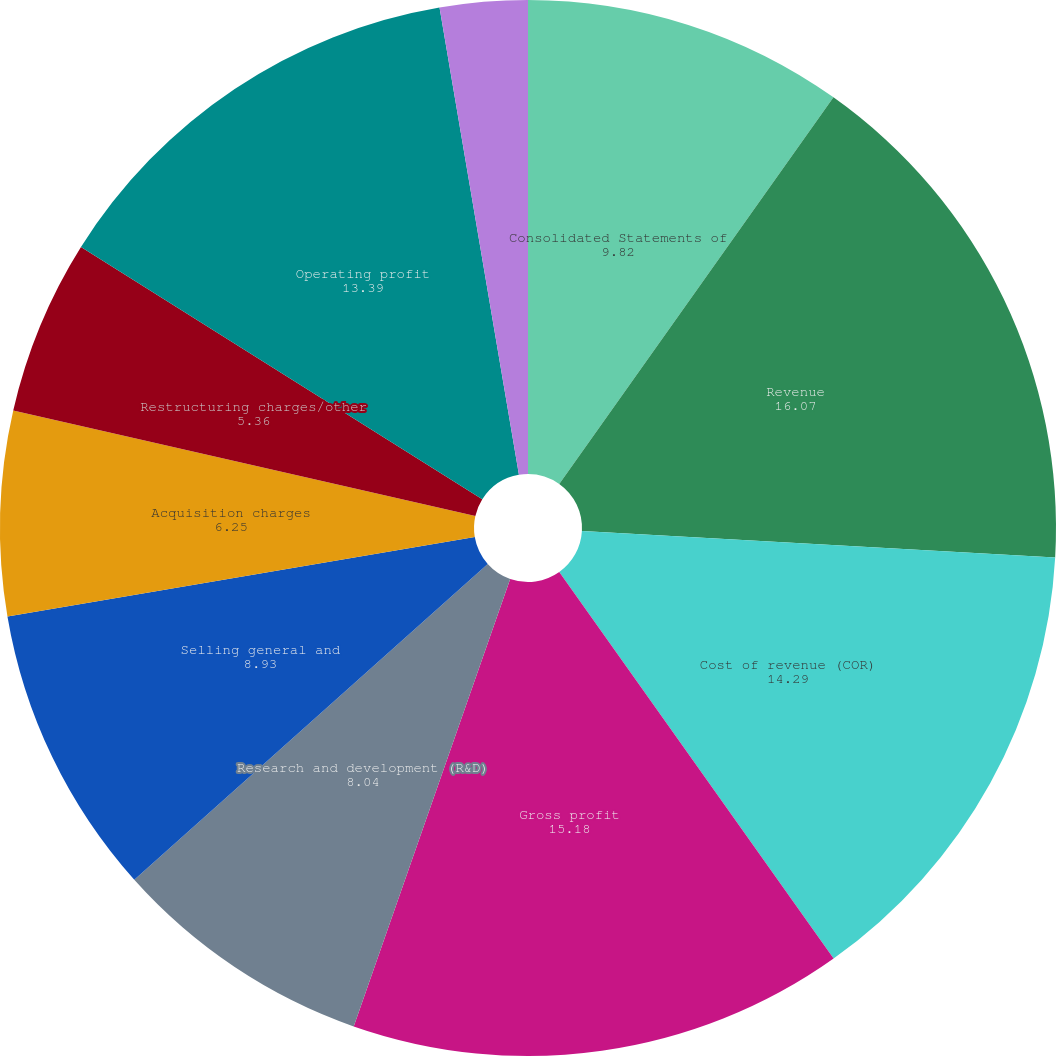Convert chart to OTSL. <chart><loc_0><loc_0><loc_500><loc_500><pie_chart><fcel>Consolidated Statements of<fcel>Revenue<fcel>Cost of revenue (COR)<fcel>Gross profit<fcel>Research and development (R&D)<fcel>Selling general and<fcel>Acquisition charges<fcel>Restructuring charges/other<fcel>Operating profit<fcel>Other income (expense) net<nl><fcel>9.82%<fcel>16.07%<fcel>14.29%<fcel>15.18%<fcel>8.04%<fcel>8.93%<fcel>6.25%<fcel>5.36%<fcel>13.39%<fcel>2.68%<nl></chart> 